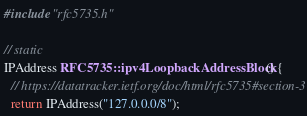Convert code to text. <code><loc_0><loc_0><loc_500><loc_500><_C++_>
#include "rfc5735.h"

// static
IPAddress RFC5735::ipv4LoopbackAddressBlock() {
  // https://datatracker.ietf.org/doc/html/rfc5735#section-3
  return IPAddress("127.0.0.0/8");</code> 